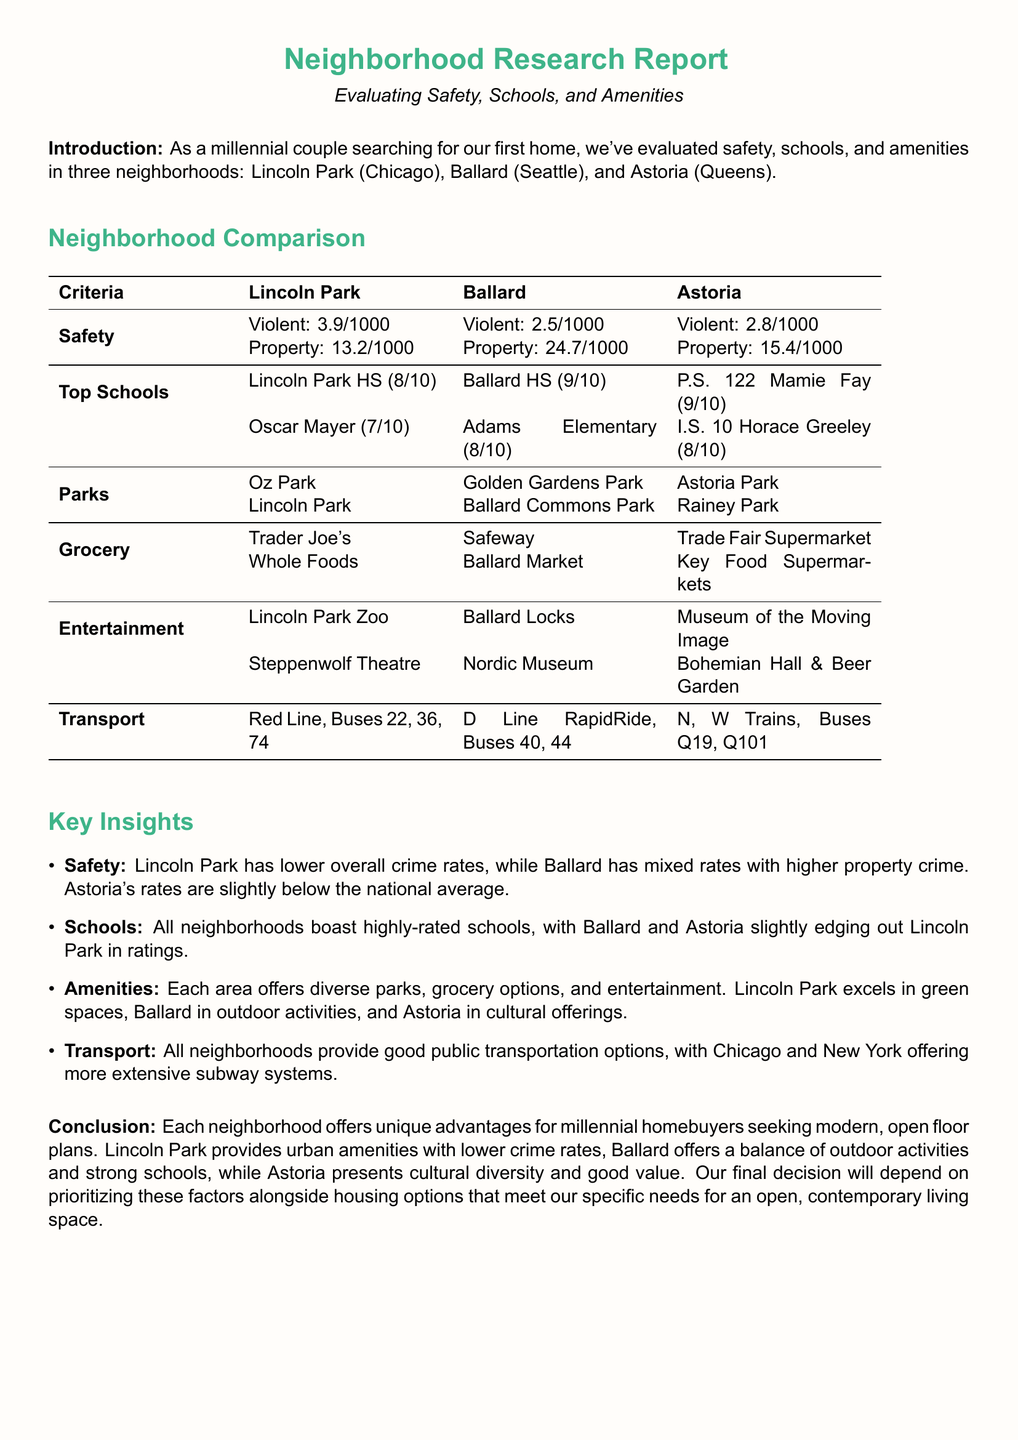what is the violent crime rate in Ballard? The violent crime rate in Ballard is indicated as 2.5 per 1000 population.
Answer: 2.5/1000 which neighborhood has the highest rated high school? The highest rated high school is in Ballard, with a rating of 9 out of 10.
Answer: Ballard HS (9/10) what are the two entertainment options listed for Astoria? The entertainment options for Astoria include the Museum of the Moving Image and Bohemian Hall & Beer Garden.
Answer: Museum of the Moving Image, Bohemian Hall & Beer Garden which area has the most parks mentioned? The document lists the most parks for Lincoln Park, with multiple parks mentioned.
Answer: Lincoln Park what is the common transportation option available in Lincoln Park? The common transportation option available in Lincoln Park includes the Red Line and several bus routes.
Answer: Red Line, Buses 22, 36, 74 which neighborhood is noted for cultural diversity? Astoria is specifically mentioned for its cultural diversity.
Answer: Astoria 